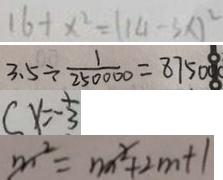<formula> <loc_0><loc_0><loc_500><loc_500>1 6 + x ^ { 2 } = ( 1 4 - 3 x ) ^ { 2 } 
 3 . 5 \div \frac { 1 } { 2 5 0 0 0 0 } = 8 7 5 0 0 0 
 ( x = - \frac { 1 } { 3 } 
 m ^ { 2 } = m ^ { 2 } + 2 m + 1</formula> 